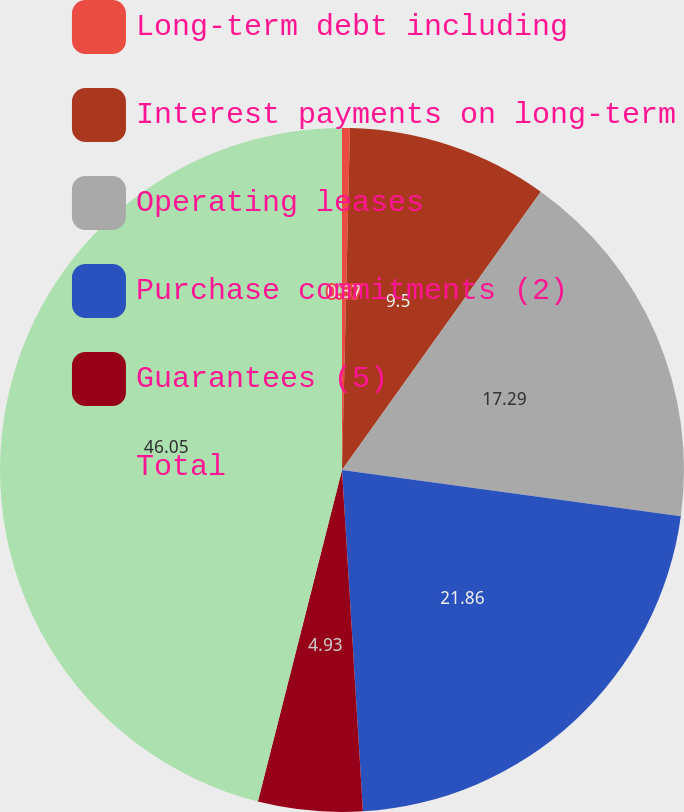Convert chart. <chart><loc_0><loc_0><loc_500><loc_500><pie_chart><fcel>Long-term debt including<fcel>Interest payments on long-term<fcel>Operating leases<fcel>Purchase commitments (2)<fcel>Guarantees (5)<fcel>Total<nl><fcel>0.37%<fcel>9.5%<fcel>17.29%<fcel>21.86%<fcel>4.93%<fcel>46.04%<nl></chart> 